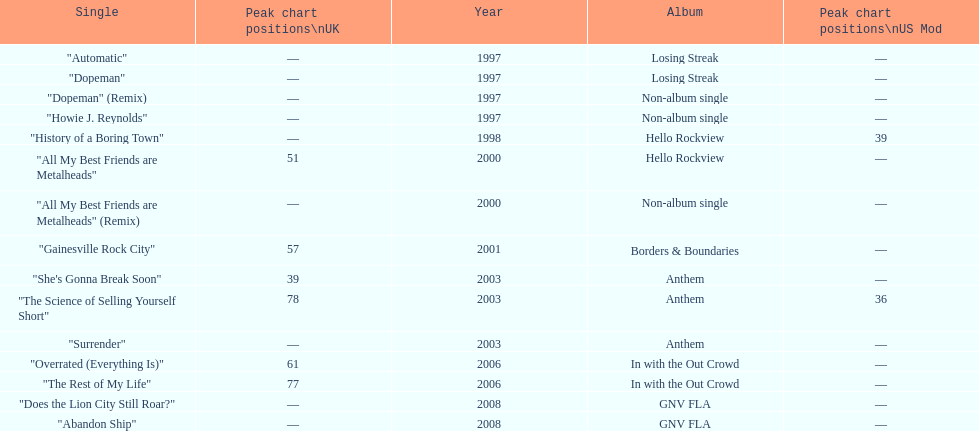What was the first single to earn a chart position? "History of a Boring Town". 